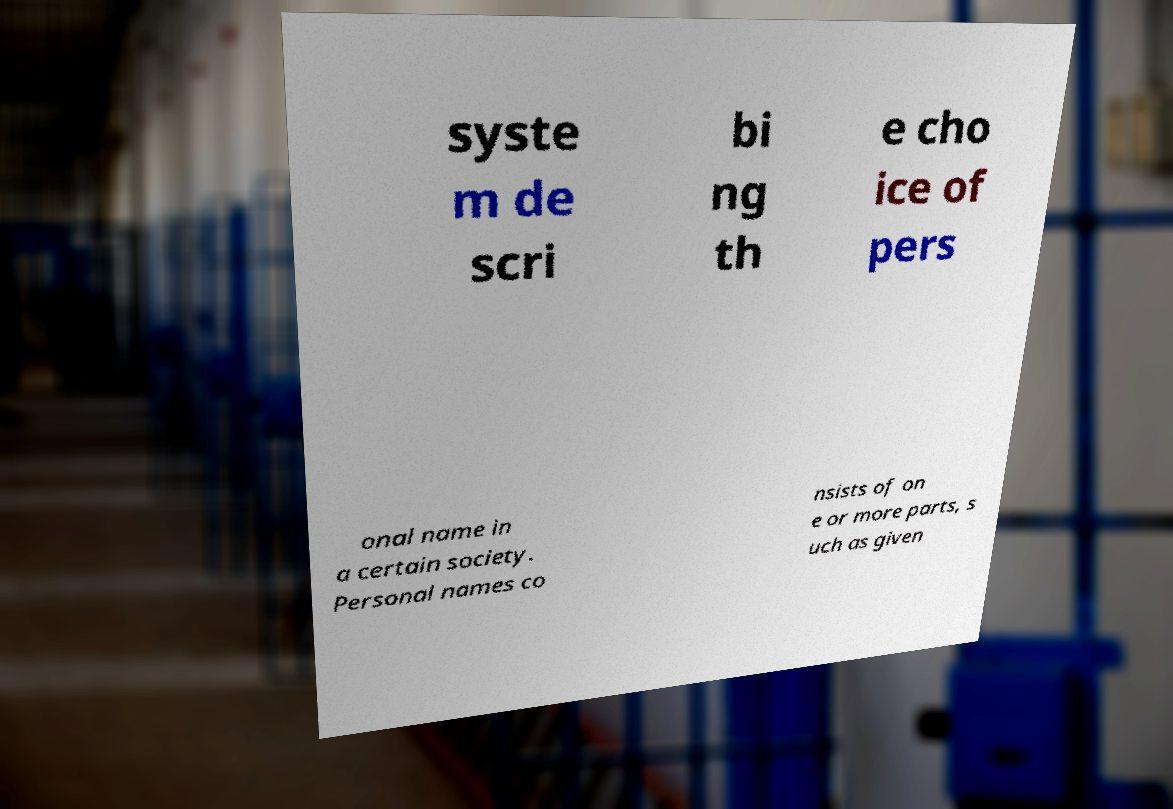What messages or text are displayed in this image? I need them in a readable, typed format. syste m de scri bi ng th e cho ice of pers onal name in a certain society. Personal names co nsists of on e or more parts, s uch as given 